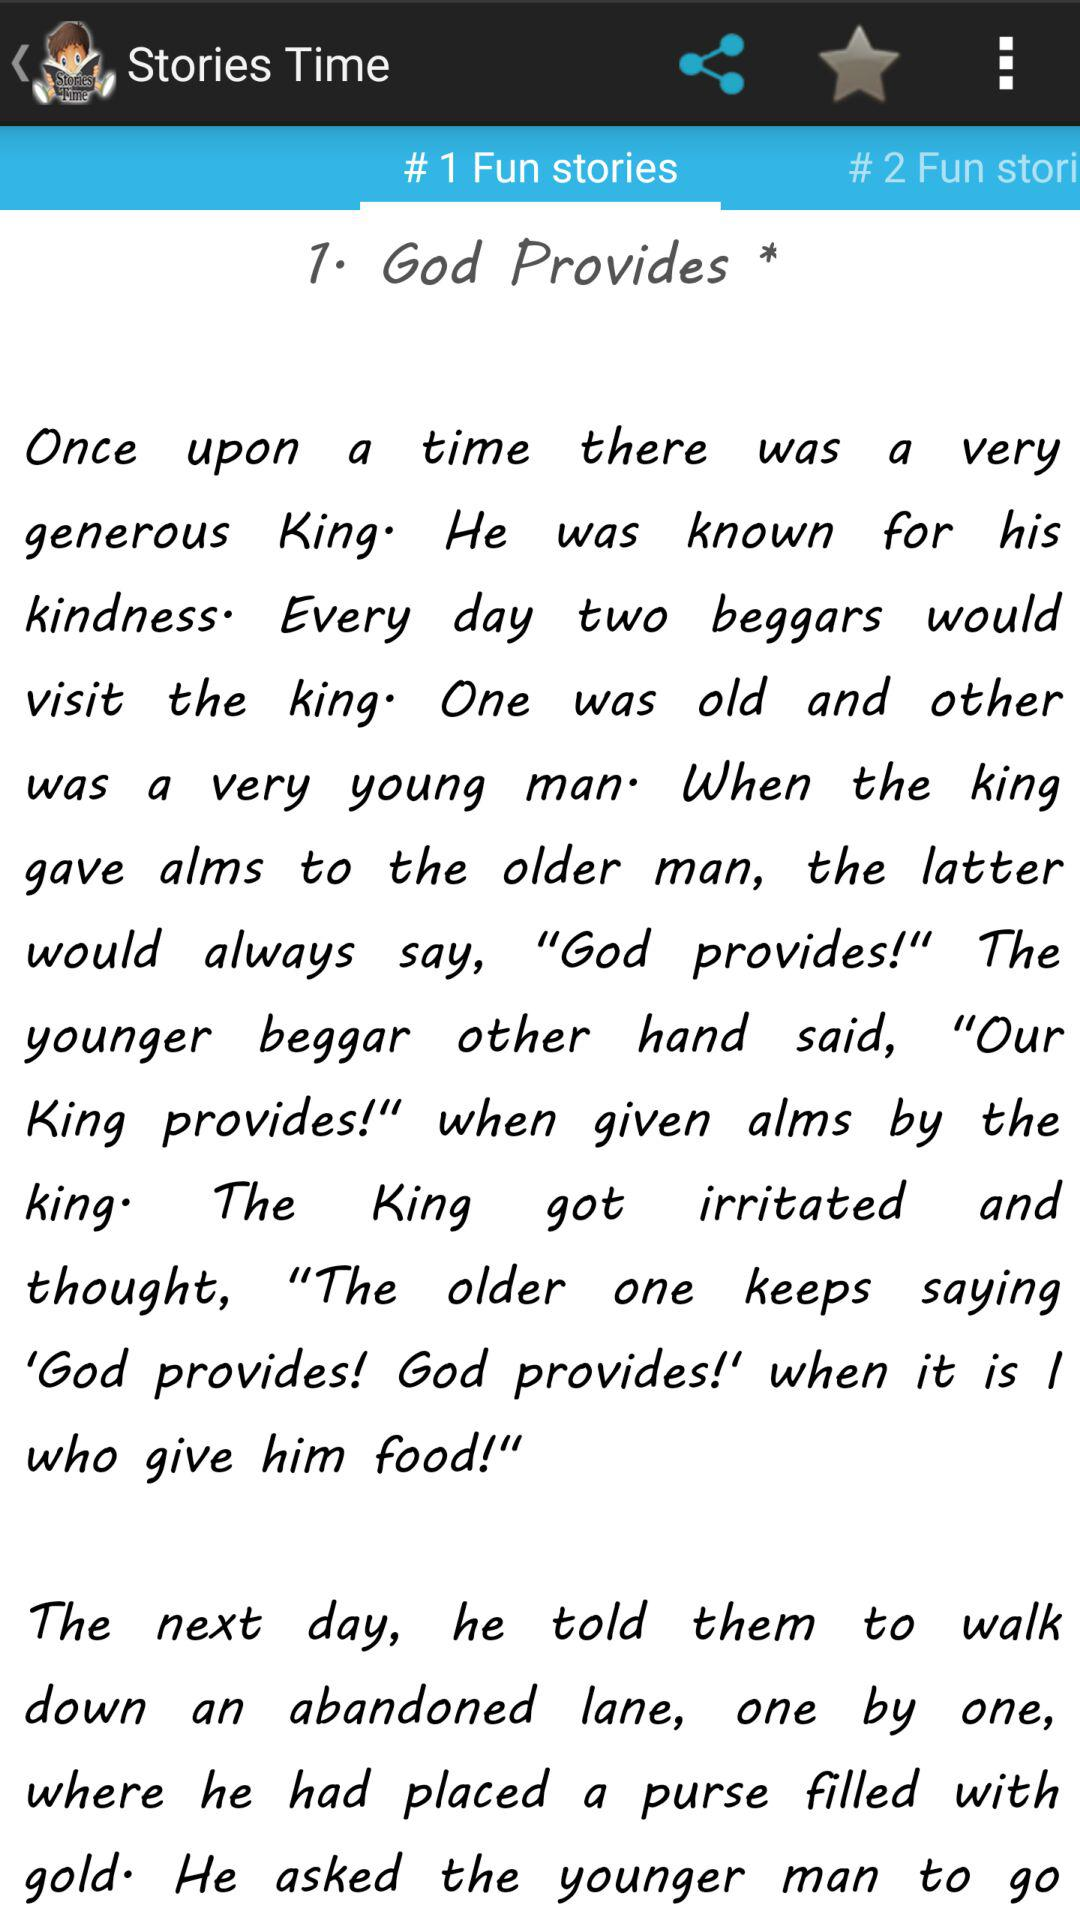What's the application name? The application name is "Stories Time". 